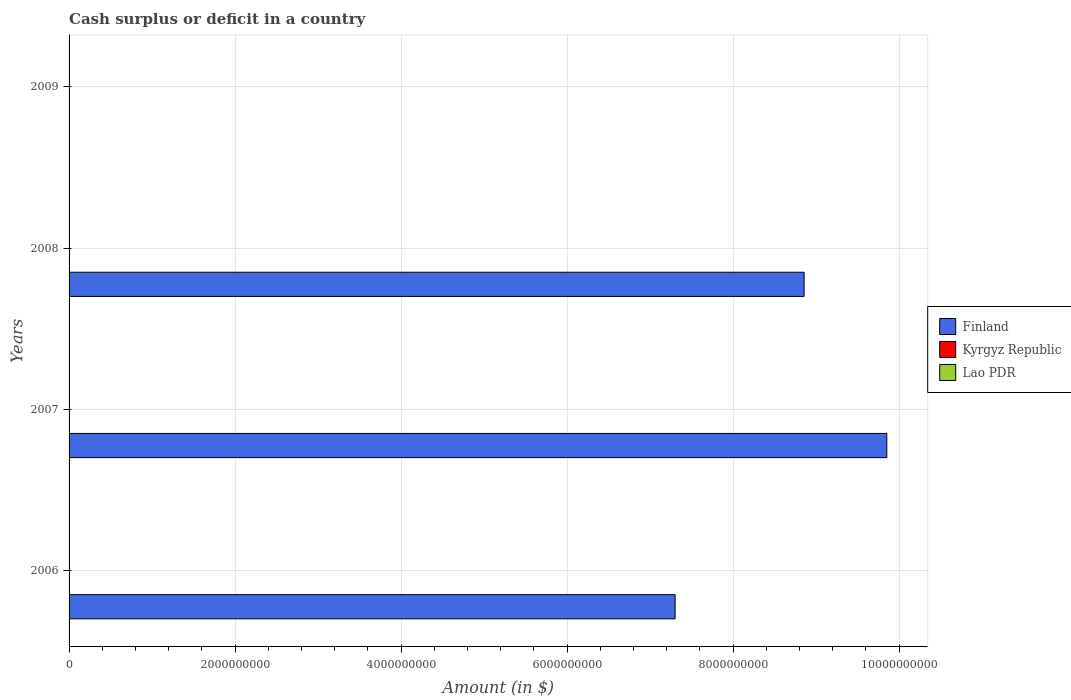How many different coloured bars are there?
Your response must be concise. 1. Are the number of bars on each tick of the Y-axis equal?
Ensure brevity in your answer.  No. What is the amount of cash surplus or deficit in Finland in 2007?
Your answer should be compact. 9.85e+09. Across all years, what is the maximum amount of cash surplus or deficit in Finland?
Offer a very short reply. 9.85e+09. Across all years, what is the minimum amount of cash surplus or deficit in Kyrgyz Republic?
Provide a succinct answer. 0. In which year was the amount of cash surplus or deficit in Finland maximum?
Your answer should be very brief. 2007. What is the difference between the amount of cash surplus or deficit in Finland in 2006 and that in 2008?
Your answer should be compact. -1.55e+09. What is the difference between the amount of cash surplus or deficit in Finland in 2006 and the amount of cash surplus or deficit in Lao PDR in 2008?
Ensure brevity in your answer.  7.30e+09. Is the amount of cash surplus or deficit in Finland in 2007 less than that in 2008?
Offer a terse response. No. What is the difference between the highest and the second highest amount of cash surplus or deficit in Finland?
Offer a very short reply. 9.96e+08. What is the difference between the highest and the lowest amount of cash surplus or deficit in Finland?
Provide a short and direct response. 9.85e+09. Is it the case that in every year, the sum of the amount of cash surplus or deficit in Kyrgyz Republic and amount of cash surplus or deficit in Finland is greater than the amount of cash surplus or deficit in Lao PDR?
Keep it short and to the point. No. Are the values on the major ticks of X-axis written in scientific E-notation?
Ensure brevity in your answer.  No. How many legend labels are there?
Provide a succinct answer. 3. How are the legend labels stacked?
Ensure brevity in your answer.  Vertical. What is the title of the graph?
Keep it short and to the point. Cash surplus or deficit in a country. Does "Botswana" appear as one of the legend labels in the graph?
Your answer should be compact. No. What is the label or title of the X-axis?
Offer a terse response. Amount (in $). What is the Amount (in $) of Finland in 2006?
Keep it short and to the point. 7.30e+09. What is the Amount (in $) of Finland in 2007?
Provide a short and direct response. 9.85e+09. What is the Amount (in $) in Lao PDR in 2007?
Offer a very short reply. 0. What is the Amount (in $) of Finland in 2008?
Provide a short and direct response. 8.86e+09. What is the Amount (in $) of Kyrgyz Republic in 2008?
Provide a succinct answer. 0. What is the Amount (in $) in Lao PDR in 2008?
Your response must be concise. 0. What is the Amount (in $) of Finland in 2009?
Offer a terse response. 0. What is the Amount (in $) in Kyrgyz Republic in 2009?
Ensure brevity in your answer.  0. Across all years, what is the maximum Amount (in $) of Finland?
Offer a very short reply. 9.85e+09. Across all years, what is the minimum Amount (in $) of Finland?
Offer a very short reply. 0. What is the total Amount (in $) in Finland in the graph?
Your response must be concise. 2.60e+1. What is the difference between the Amount (in $) in Finland in 2006 and that in 2007?
Your answer should be compact. -2.55e+09. What is the difference between the Amount (in $) in Finland in 2006 and that in 2008?
Provide a succinct answer. -1.55e+09. What is the difference between the Amount (in $) in Finland in 2007 and that in 2008?
Give a very brief answer. 9.96e+08. What is the average Amount (in $) of Finland per year?
Your response must be concise. 6.50e+09. What is the average Amount (in $) of Kyrgyz Republic per year?
Provide a succinct answer. 0. What is the average Amount (in $) of Lao PDR per year?
Offer a terse response. 0. What is the ratio of the Amount (in $) in Finland in 2006 to that in 2007?
Give a very brief answer. 0.74. What is the ratio of the Amount (in $) in Finland in 2006 to that in 2008?
Keep it short and to the point. 0.82. What is the ratio of the Amount (in $) of Finland in 2007 to that in 2008?
Your response must be concise. 1.11. What is the difference between the highest and the second highest Amount (in $) of Finland?
Keep it short and to the point. 9.96e+08. What is the difference between the highest and the lowest Amount (in $) of Finland?
Your answer should be very brief. 9.85e+09. 